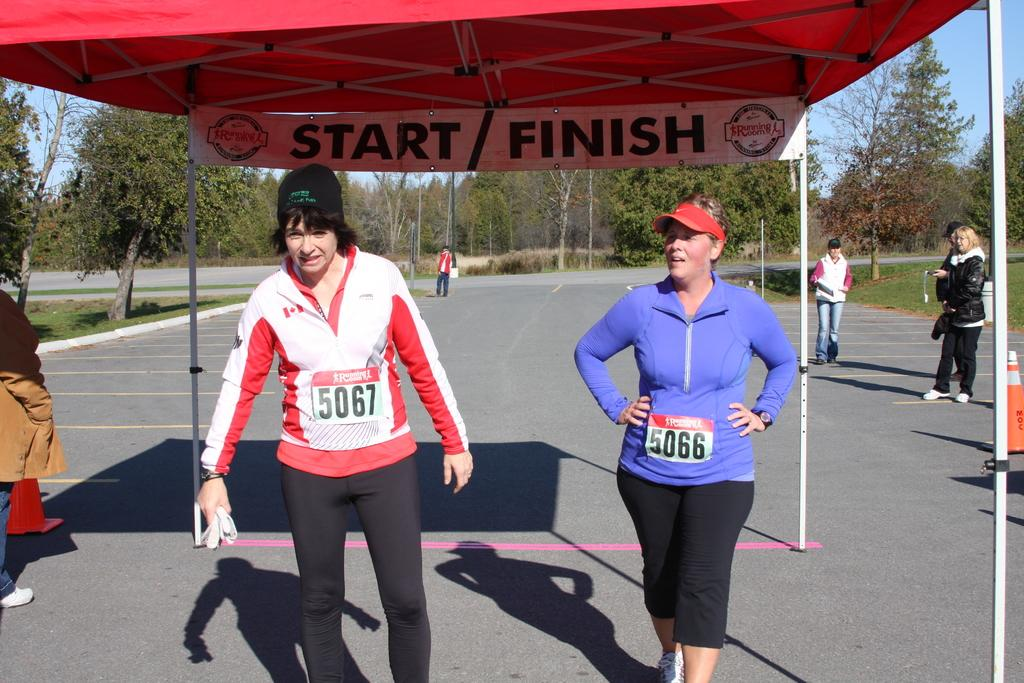What can be seen in the image involving people? There are people standing in the image. What structure is present in the image that provides shade? There is a canopy tent in the image. What type of signage is visible in the image? There is a banner in the image. What natural elements are present in the image? There are trees in the image. What man-made feature can be seen in the image? There is a road in the image. What type of desk is visible in the image? There is no desk present in the image. Is there any poison mentioned or depicted in the image? There is no mention or depiction of poison in the image. 